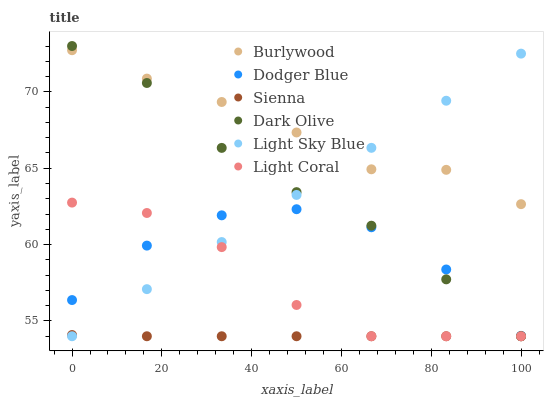Does Sienna have the minimum area under the curve?
Answer yes or no. Yes. Does Burlywood have the maximum area under the curve?
Answer yes or no. Yes. Does Dark Olive have the minimum area under the curve?
Answer yes or no. No. Does Dark Olive have the maximum area under the curve?
Answer yes or no. No. Is Light Sky Blue the smoothest?
Answer yes or no. Yes. Is Dodger Blue the roughest?
Answer yes or no. Yes. Is Burlywood the smoothest?
Answer yes or no. No. Is Burlywood the roughest?
Answer yes or no. No. Does Light Coral have the lowest value?
Answer yes or no. Yes. Does Burlywood have the lowest value?
Answer yes or no. No. Does Dark Olive have the highest value?
Answer yes or no. Yes. Does Burlywood have the highest value?
Answer yes or no. No. Is Dodger Blue less than Burlywood?
Answer yes or no. Yes. Is Burlywood greater than Sienna?
Answer yes or no. Yes. Does Dodger Blue intersect Dark Olive?
Answer yes or no. Yes. Is Dodger Blue less than Dark Olive?
Answer yes or no. No. Is Dodger Blue greater than Dark Olive?
Answer yes or no. No. Does Dodger Blue intersect Burlywood?
Answer yes or no. No. 